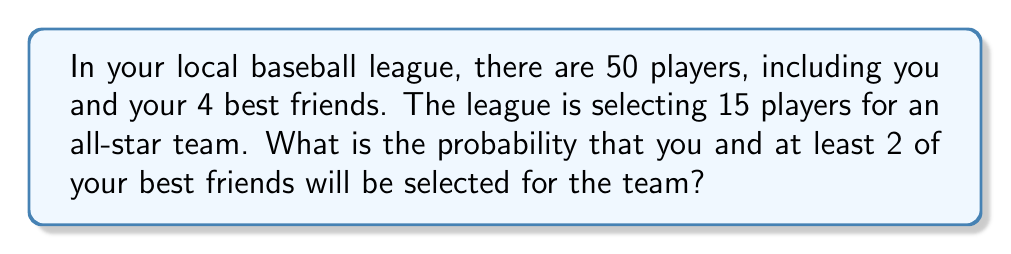Help me with this question. Let's approach this step-by-step:

1) First, we need to calculate the total number of ways to select 15 players from 50. This is given by the combination formula:

   $$\binom{50}{15} = \frac{50!}{15!(50-15)!} = \frac{50!}{15!35!}$$

2) Now, we need to calculate the favorable outcomes. We want you and at least 2 of your friends to be selected. Let's break this down:

   - You must be selected (1 spot)
   - At least 2 of your 4 friends must be selected
   - The remaining spots can be filled by anyone else

3) We can calculate this as the sum of three scenarios:
   a) You + 2 friends + 12 others
   b) You + 3 friends + 11 others
   c) You + 4 friends + 10 others

4) Let's calculate each scenario:

   a) $$\binom{4}{2} \cdot \binom{45}{12}$$
   b) $$\binom{4}{3} \cdot \binom{45}{11}$$
   c) $$\binom{4}{4} \cdot \binom{45}{10}$$

5) The total number of favorable outcomes is the sum of these:

   $$\binom{4}{2} \cdot \binom{45}{12} + \binom{4}{3} \cdot \binom{45}{11} + \binom{4}{4} \cdot \binom{45}{10}$$

6) The probability is then:

   $$P = \frac{\binom{4}{2} \cdot \binom{45}{12} + \binom{4}{3} \cdot \binom{45}{11} + \binom{4}{4} \cdot \binom{45}{10}}{\binom{50}{15}}$$

7) Calculating this:

   $$P = \frac{6 \cdot 7726160 + 4 \cdot 3176716 + 1 \cdot 1221759}{2250829575}$$

   $$P = \frac{59863674}{2250829575} \approx 0.0266$$
Answer: $\frac{59863674}{2250829575} \approx 0.0266$ or about $2.66\%$ 